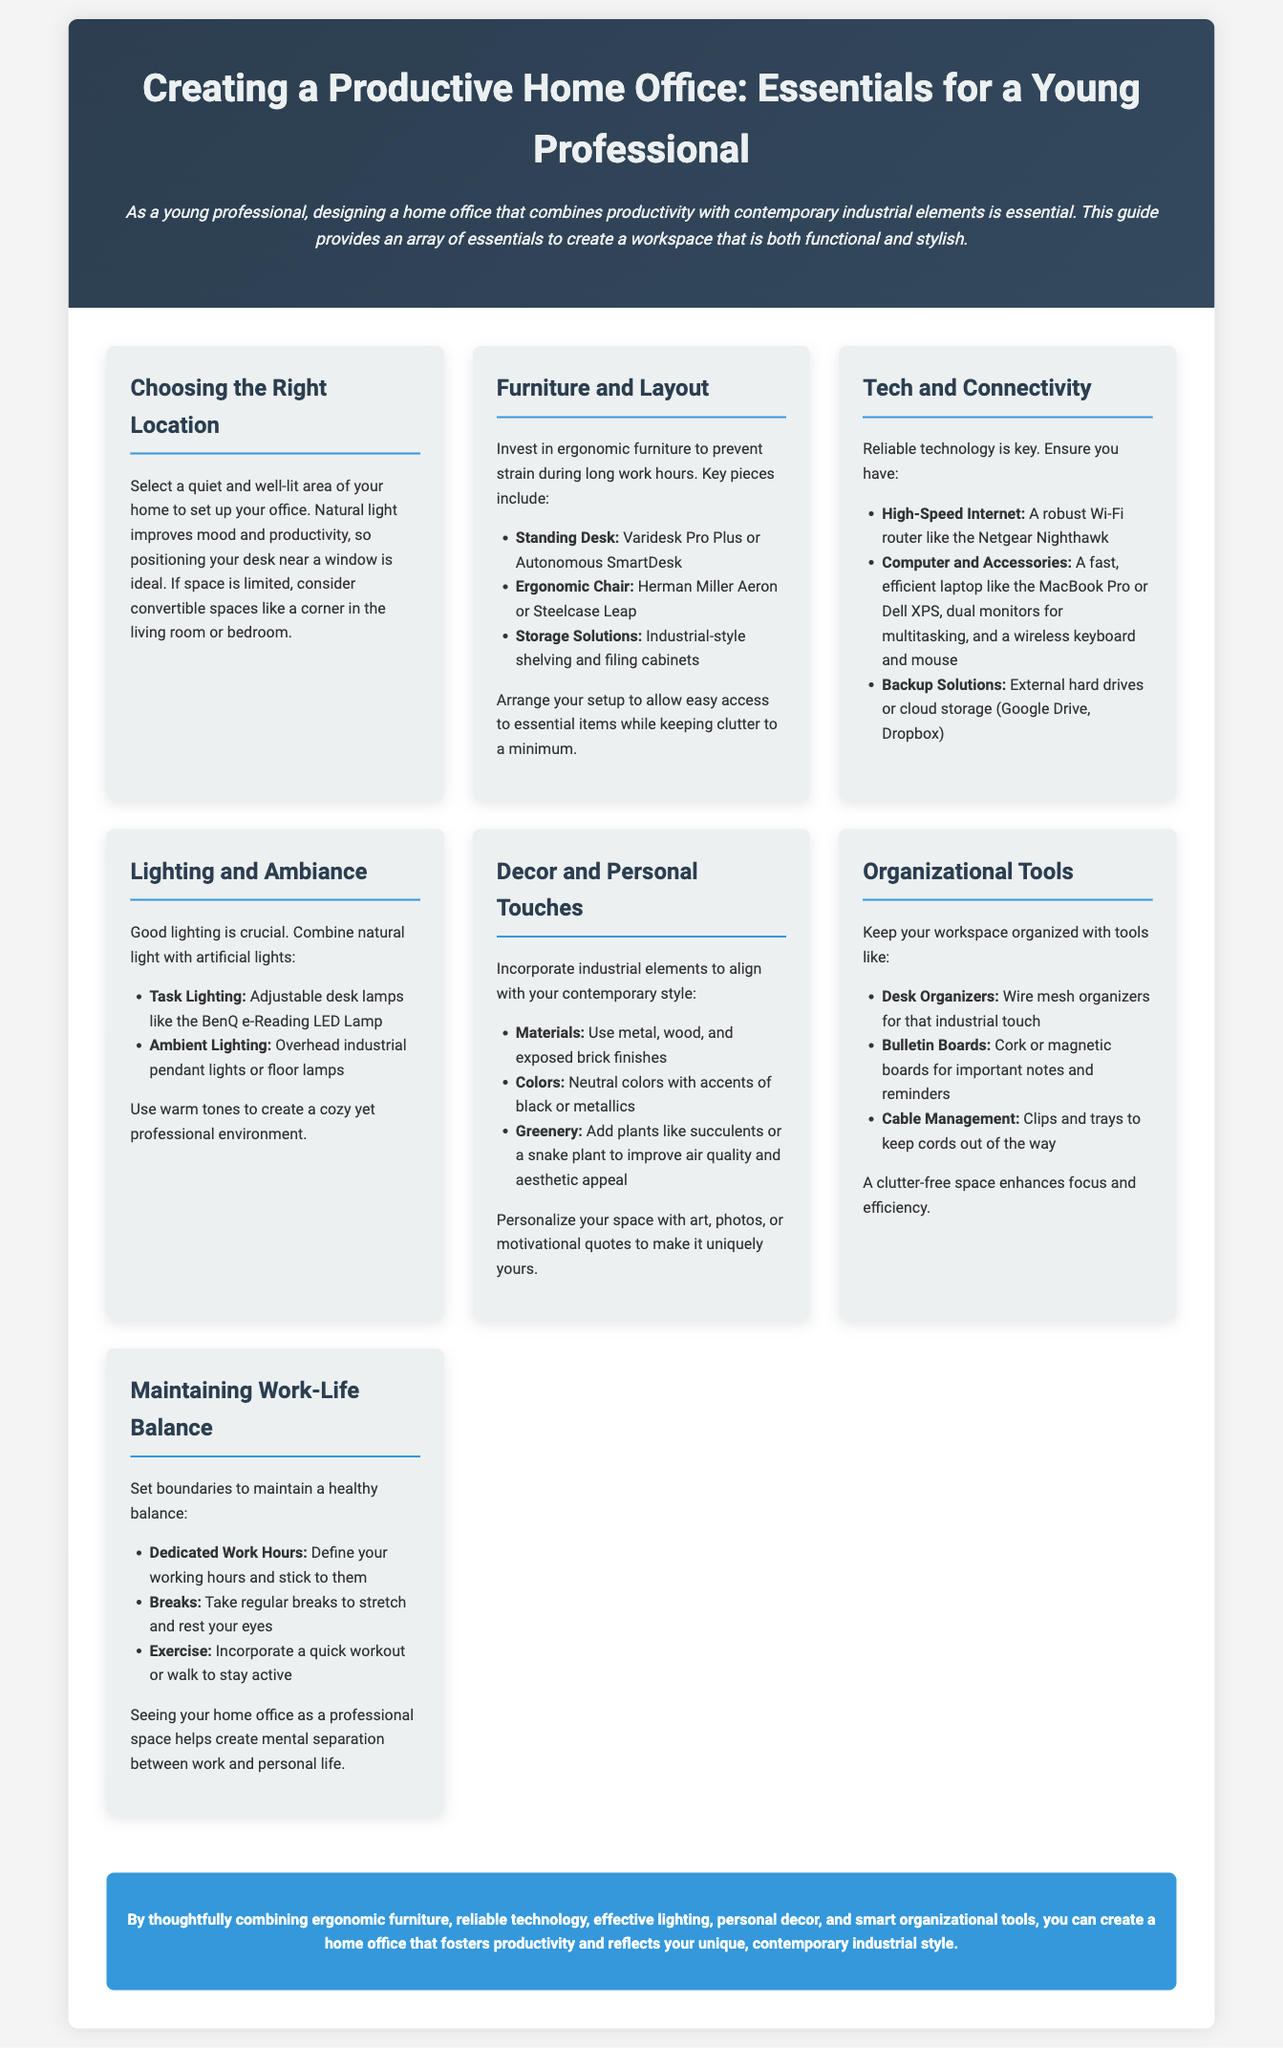What is the recommended desk type? The document recommends a "standing desk" as an essential furniture piece for a productive home office.
Answer: standing desk Which ergonomic chair is suggested? The guide specifically mentions the "Herman Miller Aeron" as a recommended ergonomic chair for comfort during work hours.
Answer: Herman Miller Aeron What is a key benefit of natural light? The document states that natural light "improves mood and productivity," highlighting its importance in an office setup.
Answer: improves mood and productivity What type of lighting is essential for a home office? The guide emphasizes combining "natural light with artificial lights" to ensure proper lighting.
Answer: natural light with artificial lights Which plants are recommended for décor? The document suggests "succulents" or a "snake plant" to enhance air quality and aesthetic appeal in the workspace.
Answer: succulents or a snake plant What is the purpose of organizational tools? The document indicates that organizational tools help maintain a "clutter-free space," which enhances focus and efficiency.
Answer: clutter-free space How should work hours be defined? The document recommends defining "dedicated work hours" as a strategy for maintaining a work-life balance.
Answer: dedicated work hours What furniture solution is suggested for storage? The guide mentions using "industrial-style shelving" and "filing cabinets" as storage solutions in the office.
Answer: industrial-style shelving and filing cabinets What technology is recommended for high-speed internet? The guide suggests using a "robust Wi-Fi router" like the Netgear Nighthawk for reliable connectivity.
Answer: Netgear Nighthawk 